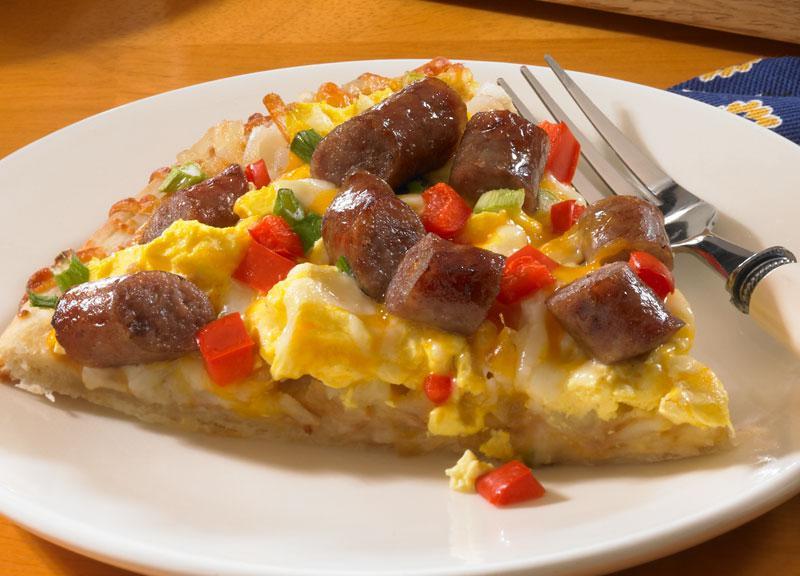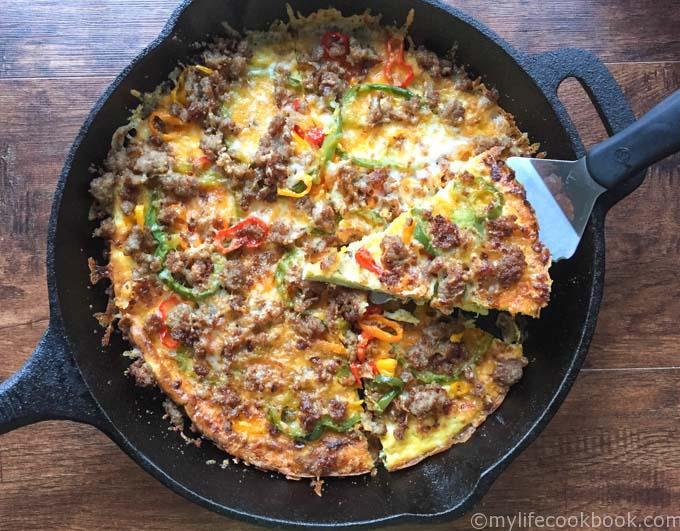The first image is the image on the left, the second image is the image on the right. Assess this claim about the two images: "There are whole tomatoes next to the pizza only in the image on the left.". Correct or not? Answer yes or no. No. The first image is the image on the left, the second image is the image on the right. Considering the images on both sides, is "Fewer than two slices of pizza can be seen on a white plate." valid? Answer yes or no. Yes. 